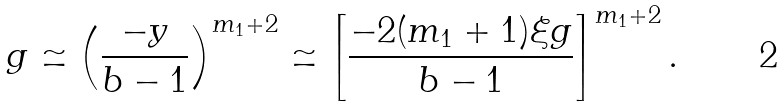Convert formula to latex. <formula><loc_0><loc_0><loc_500><loc_500>g \simeq \left ( \frac { - y } { b - 1 } \right ) ^ { m _ { 1 } + 2 } \simeq \left [ \frac { - 2 ( m _ { 1 } + 1 ) \xi g } { b - 1 } \right ] ^ { m _ { 1 } + 2 } .</formula> 